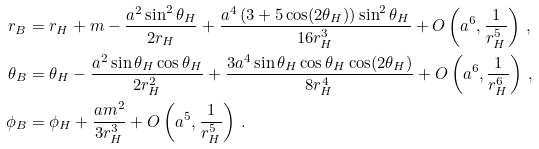<formula> <loc_0><loc_0><loc_500><loc_500>r _ { B } & = r _ { H } + m - \frac { a ^ { 2 } \sin ^ { 2 } \theta _ { H } } { 2 r _ { H } } + \frac { a ^ { 4 } \left ( 3 + 5 \cos ( 2 \theta _ { H } ) \right ) \sin ^ { 2 } \theta _ { H } } { 1 6 r _ { H } ^ { 3 } } + O \left ( a ^ { 6 } , \frac { 1 } { r _ { H } ^ { 5 } } \right ) \, , \\ \theta _ { B } & = \theta _ { H } - \frac { a ^ { 2 } \sin \theta _ { H } \cos \theta _ { H } } { 2 r _ { H } ^ { 2 } } + \frac { 3 a ^ { 4 } \sin \theta _ { H } \cos \theta _ { H } \cos ( 2 \theta _ { H } ) } { 8 r _ { H } ^ { 4 } } + O \left ( a ^ { 6 } , \frac { 1 } { r _ { H } ^ { 6 } } \right ) \, , \\ \phi _ { B } & = \phi _ { H } + \frac { a m ^ { 2 } } { 3 r _ { H } ^ { 3 } } + O \left ( a ^ { 5 } , \frac { 1 } { r _ { H } ^ { 5 } } \right ) \, .</formula> 